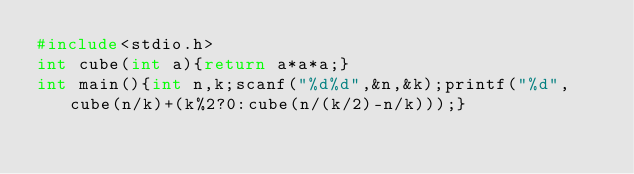Convert code to text. <code><loc_0><loc_0><loc_500><loc_500><_C_>#include<stdio.h>
int cube(int a){return a*a*a;}
int main(){int n,k;scanf("%d%d",&n,&k);printf("%d",cube(n/k)+(k%2?0:cube(n/(k/2)-n/k)));}</code> 